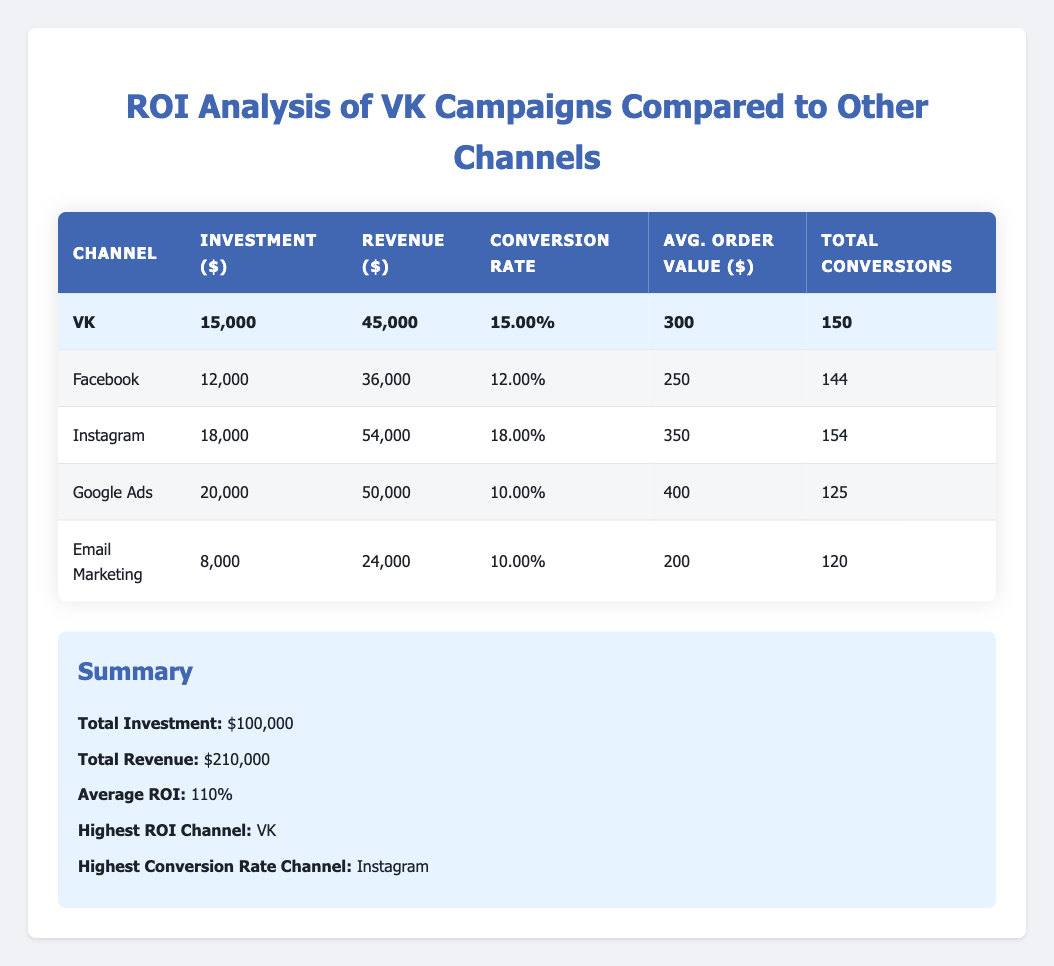What is the investment for the VK channel? Referring to the table, the investment for the VK channel is directly listed under the Investment column as $15,000.
Answer: $15,000 Which channel generated the highest revenue? By examining the Revenue column in the table, VK generated $45,000, which is the highest compared to other channels.
Answer: VK What is the average order value for Instagram? The average order value for Instagram is listed under the Avg. Order Value column as $350.
Answer: $350 How much total revenue did all channels generate? To find the total revenue, you sum the revenue from all channels: $45,000 (VK) + $36,000 (Facebook) + $54,000 (Instagram) + $50,000 (Google Ads) + $24,000 (Email Marketing) = $210,000.
Answer: $210,000 Does VK have the highest conversion rate compared to other channels? Comparing the conversion rates in the table, VK has a conversion rate of 15%, while Instagram has 18% which is higher. Thus, VK does not have the highest.
Answer: No What is the total investment across all channels? The total investment is calculated by adding the investment amounts for all channels: $15,000 (VK) + $12,000 (Facebook) + $18,000 (Instagram) + $20,000 (Google Ads) + $8,000 (Email Marketing) = $73,000.
Answer: $73,000 Which channel has a conversion rate lower than 15%? Looking at the Conversion Rate column, both Google Ads (10%) and Email Marketing (10%) have conversion rates lower than VK's 15%.
Answer: Google Ads and Email Marketing What is the average ROI of all channels? The average ROI is provided in the summary, which states that the average ROI is 110%.
Answer: 110% Which channel resulted in more total conversions, VK or Facebook? VK resulted in 150 conversions while Facebook resulted in 144 conversions. Therefore, VK had more total conversions.
Answer: VK What is the average conversion rate for all channels? To compute the average conversion rate, we sum the conversion rates: 0.15 (VK) + 0.12 (Facebook) + 0.18 (Instagram) + 0.10 (Google Ads) + 0.10 (Email Marketing) = 0.75. There are 5 channels, so the average conversion rate is 0.75 / 5 = 0.15 or 15%.
Answer: 15% 